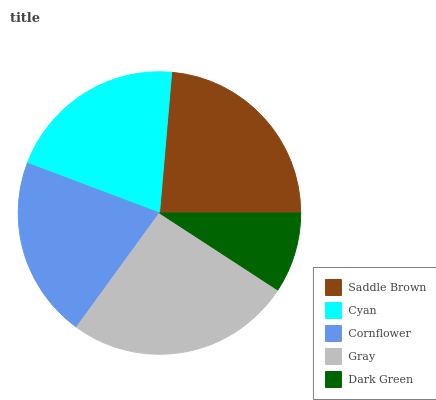Is Dark Green the minimum?
Answer yes or no. Yes. Is Gray the maximum?
Answer yes or no. Yes. Is Cyan the minimum?
Answer yes or no. No. Is Cyan the maximum?
Answer yes or no. No. Is Saddle Brown greater than Cyan?
Answer yes or no. Yes. Is Cyan less than Saddle Brown?
Answer yes or no. Yes. Is Cyan greater than Saddle Brown?
Answer yes or no. No. Is Saddle Brown less than Cyan?
Answer yes or no. No. Is Cornflower the high median?
Answer yes or no. Yes. Is Cornflower the low median?
Answer yes or no. Yes. Is Cyan the high median?
Answer yes or no. No. Is Gray the low median?
Answer yes or no. No. 